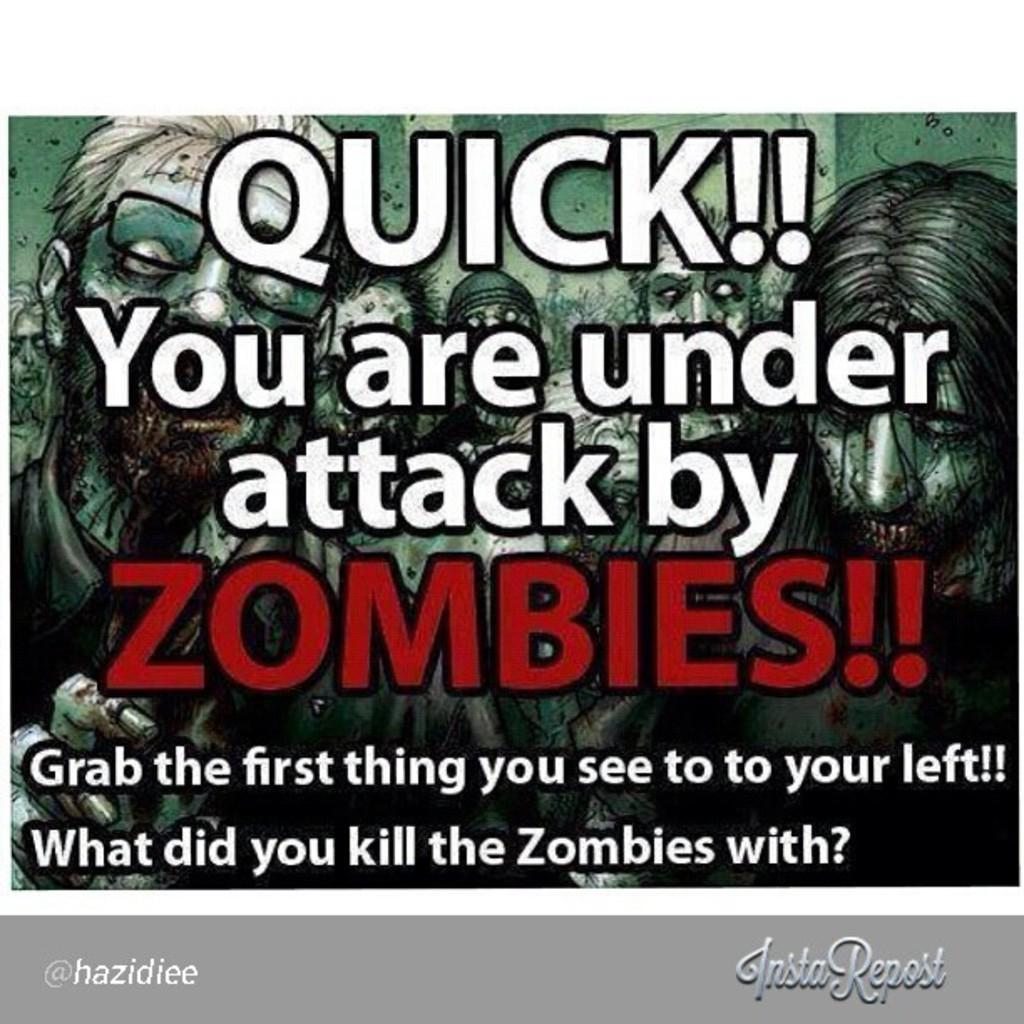What type of content is featured in the image? The image contains an animation. What kind of characters are present in the animation? There are zombies in the animation. Is there any text included in the image? Yes, there is text written on the image. How many boats can be seen in the image? There are no boats present in the image; it features an animation with zombies and text. What type of band is performing in the image? There is no band present in the image; it contains an animation with zombies and text. 